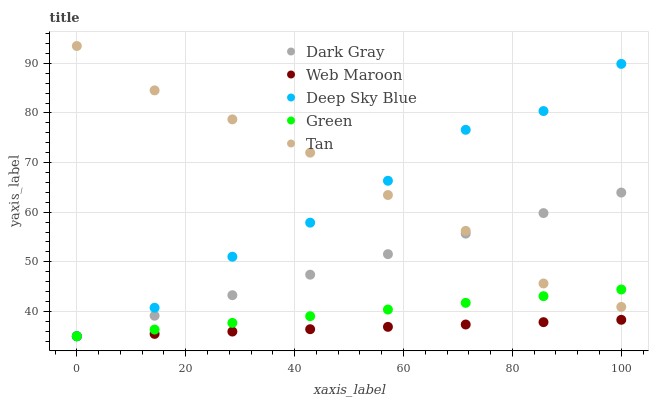Does Web Maroon have the minimum area under the curve?
Answer yes or no. Yes. Does Tan have the maximum area under the curve?
Answer yes or no. Yes. Does Green have the minimum area under the curve?
Answer yes or no. No. Does Green have the maximum area under the curve?
Answer yes or no. No. Is Green the smoothest?
Answer yes or no. Yes. Is Deep Sky Blue the roughest?
Answer yes or no. Yes. Is Tan the smoothest?
Answer yes or no. No. Is Tan the roughest?
Answer yes or no. No. Does Dark Gray have the lowest value?
Answer yes or no. Yes. Does Tan have the lowest value?
Answer yes or no. No. Does Tan have the highest value?
Answer yes or no. Yes. Does Green have the highest value?
Answer yes or no. No. Is Web Maroon less than Tan?
Answer yes or no. Yes. Is Tan greater than Web Maroon?
Answer yes or no. Yes. Does Dark Gray intersect Green?
Answer yes or no. Yes. Is Dark Gray less than Green?
Answer yes or no. No. Is Dark Gray greater than Green?
Answer yes or no. No. Does Web Maroon intersect Tan?
Answer yes or no. No. 